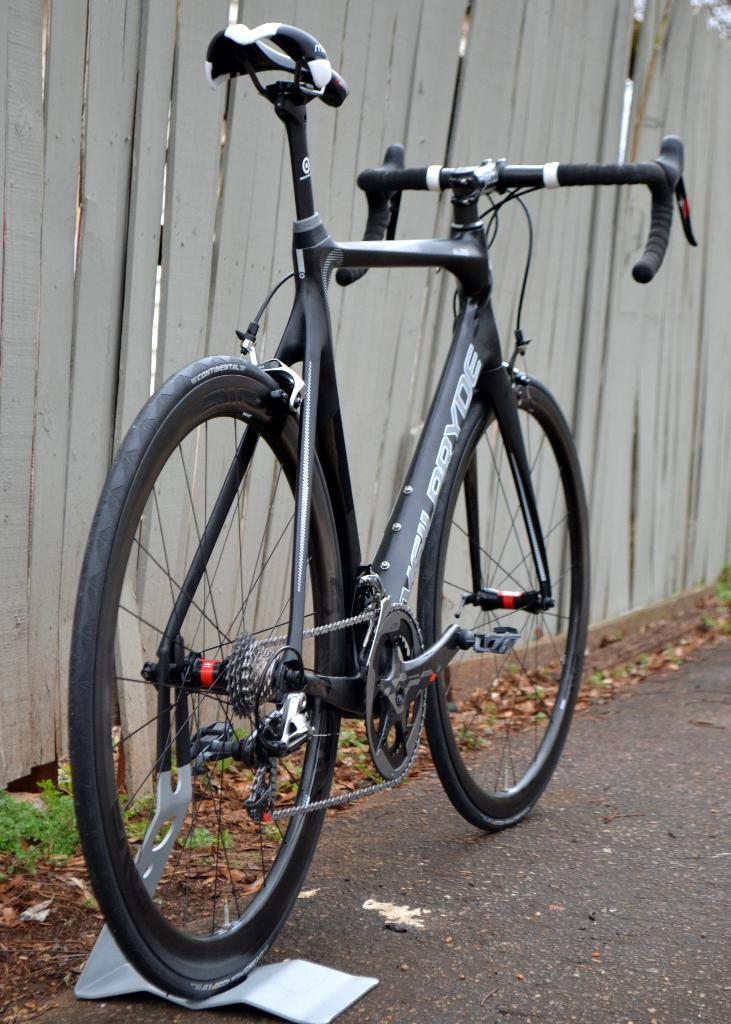What type of vehicle is in the image? There is a bicycle with a stand in the image. Where is the bicycle located? The bicycle is on the road. What can be seen in the background of the image? There is wooden fencing in the background of the image. Are there any plants visible in the image? Yes, there are plants visible in the image. How many thumbs can be seen on the bicycle in the image? There are no thumbs visible on the bicycle in the image. Can you tell if the person riding the bicycle is walking or sleeping? There is no person riding the bicycle in the image, so it cannot be determined if they are walking or sleeping. 